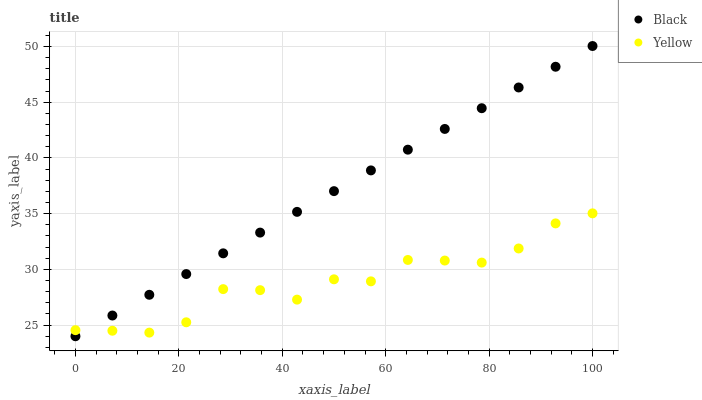Does Yellow have the minimum area under the curve?
Answer yes or no. Yes. Does Black have the maximum area under the curve?
Answer yes or no. Yes. Does Yellow have the maximum area under the curve?
Answer yes or no. No. Is Black the smoothest?
Answer yes or no. Yes. Is Yellow the roughest?
Answer yes or no. Yes. Is Yellow the smoothest?
Answer yes or no. No. Does Black have the lowest value?
Answer yes or no. Yes. Does Yellow have the lowest value?
Answer yes or no. No. Does Black have the highest value?
Answer yes or no. Yes. Does Yellow have the highest value?
Answer yes or no. No. Does Yellow intersect Black?
Answer yes or no. Yes. Is Yellow less than Black?
Answer yes or no. No. Is Yellow greater than Black?
Answer yes or no. No. 